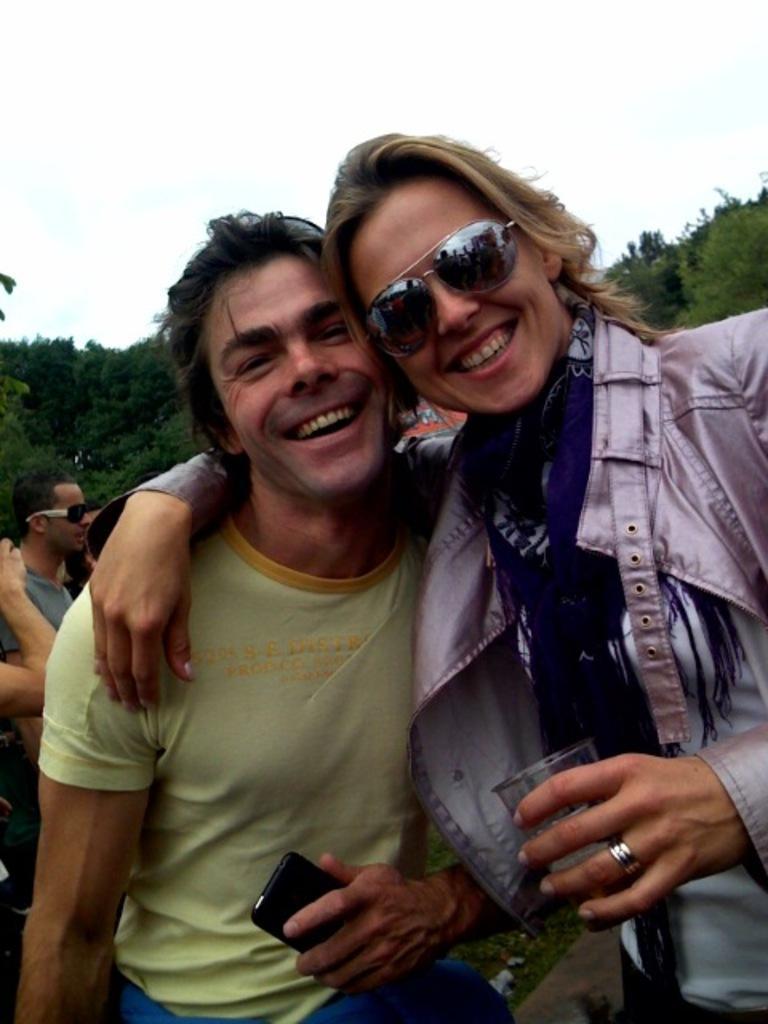How would you summarize this image in a sentence or two? In this image I can see a group of people on the road, mobile, glass, goggles. In the background I can see trees and the sky. This image is taken may be during a day. 